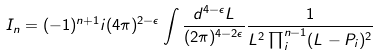Convert formula to latex. <formula><loc_0><loc_0><loc_500><loc_500>I _ { n } = ( - 1 ) ^ { n + 1 } i ( 4 \pi ) ^ { 2 - \epsilon } \int \frac { d ^ { 4 - \epsilon } L } { ( 2 \pi ) ^ { 4 - 2 \epsilon } } \frac { 1 } { L ^ { 2 } \prod _ { i } ^ { n - 1 } ( L - P _ { i } ) ^ { 2 } }</formula> 